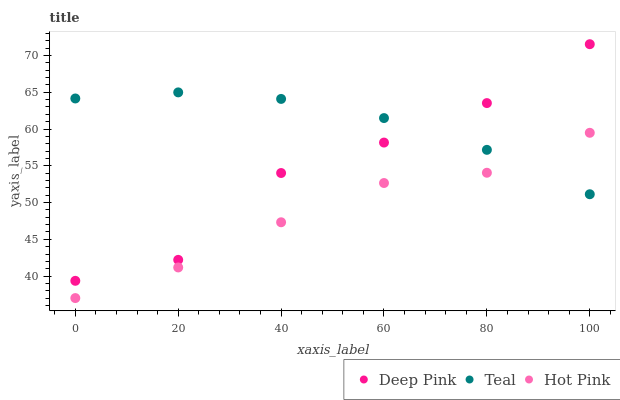Does Hot Pink have the minimum area under the curve?
Answer yes or no. Yes. Does Teal have the maximum area under the curve?
Answer yes or no. Yes. Does Teal have the minimum area under the curve?
Answer yes or no. No. Does Hot Pink have the maximum area under the curve?
Answer yes or no. No. Is Teal the smoothest?
Answer yes or no. Yes. Is Deep Pink the roughest?
Answer yes or no. Yes. Is Hot Pink the smoothest?
Answer yes or no. No. Is Hot Pink the roughest?
Answer yes or no. No. Does Hot Pink have the lowest value?
Answer yes or no. Yes. Does Teal have the lowest value?
Answer yes or no. No. Does Deep Pink have the highest value?
Answer yes or no. Yes. Does Teal have the highest value?
Answer yes or no. No. Is Hot Pink less than Deep Pink?
Answer yes or no. Yes. Is Deep Pink greater than Hot Pink?
Answer yes or no. Yes. Does Teal intersect Deep Pink?
Answer yes or no. Yes. Is Teal less than Deep Pink?
Answer yes or no. No. Is Teal greater than Deep Pink?
Answer yes or no. No. Does Hot Pink intersect Deep Pink?
Answer yes or no. No. 